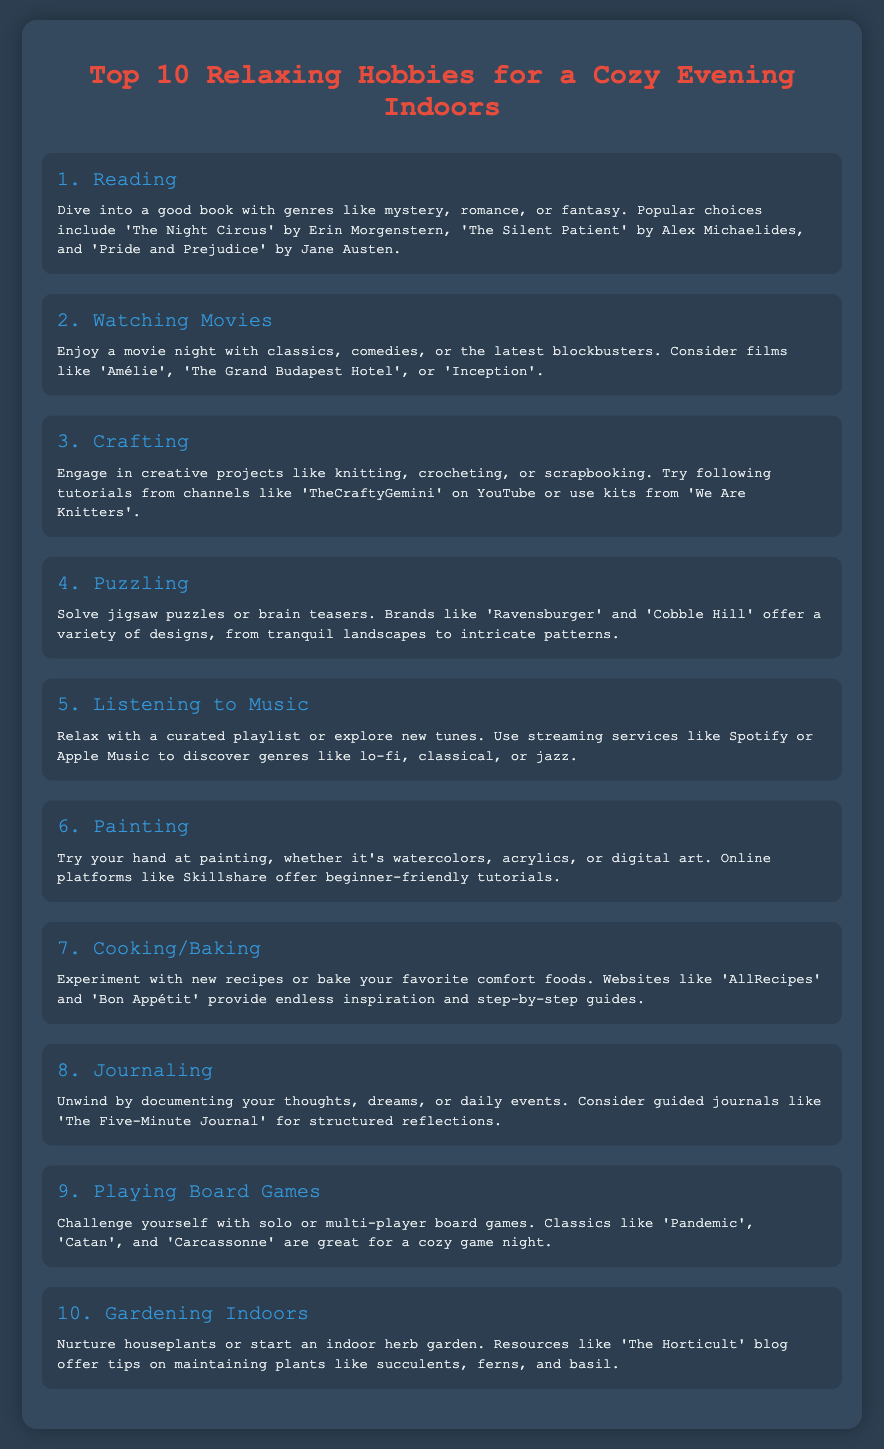What is the first hobby listed? The first hobby listed in the document is "Reading."
Answer: Reading How many hobbies are there in total? The document lists a total of 10 hobbies.
Answer: 10 Which hobby involves creating projects like knitting? The hobby that involves creating projects like knitting is "Crafting."
Answer: Crafting What type of music is recommended for relaxation? The document suggests genres like "lo-fi, classical, or jazz" for relaxation.
Answer: lo-fi, classical, or jazz What is a suggested activity for journaling? A suggested journaling activity is "documenting your thoughts, dreams, or daily events."
Answer: documenting your thoughts, dreams, or daily events Which genre of books is mentioned as popular in the reading section? A popular genre mentioned is "mystery."
Answer: mystery Name one streaming service recommended for music. One streaming service mentioned for music is "Spotify."
Answer: Spotify What is a popular board game listed in the document? A popular board game listed is "Pandemic."
Answer: Pandemic Which hobby is associated with indoor plants? The hobby associated with indoor plants is "Gardening Indoors."
Answer: Gardening Indoors What creative activity is highlighted for painting? The document highlights "online platforms like Skillshare" for painting tutorials.
Answer: online platforms like Skillshare 